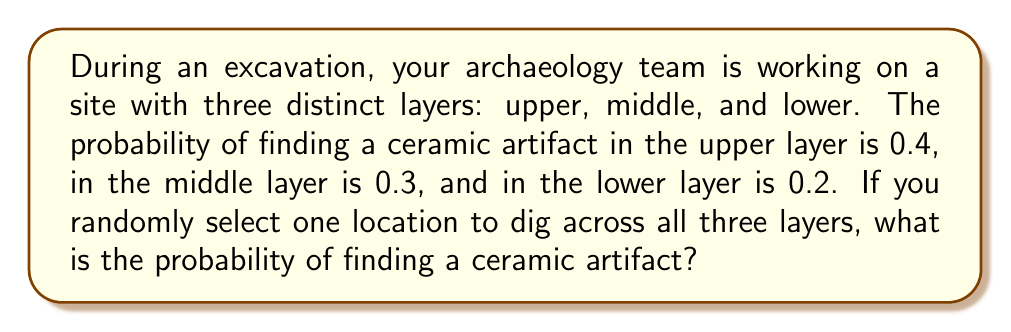Can you answer this question? Let's approach this step-by-step:

1) First, we need to recognize that this is a problem of mutually exclusive events. Finding a ceramic artifact in one layer excludes the possibility of finding it in another layer.

2) In probability theory, when we have mutually exclusive events, we can add their individual probabilities to find the total probability.

3) Let's define our events:
   $A$ = finding a ceramic artifact in the upper layer
   $B$ = finding a ceramic artifact in the middle layer
   $C$ = finding a ceramic artifact in the lower layer

4) We're given the following probabilities:
   $P(A) = 0.4$
   $P(B) = 0.3$
   $P(C) = 0.2$

5) The probability of finding a ceramic artifact in any of the three layers is the sum of these individual probabilities:

   $P(\text{finding a ceramic artifact}) = P(A) + P(B) + P(C)$

6) Substituting the values:

   $P(\text{finding a ceramic artifact}) = 0.4 + 0.3 + 0.2 = 0.9$

Therefore, the probability of finding a ceramic artifact when randomly selecting one location to dig across all three layers is 0.9 or 90%.
Answer: 0.9 